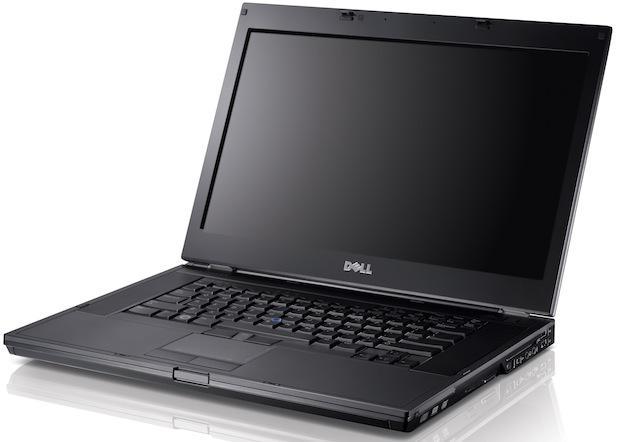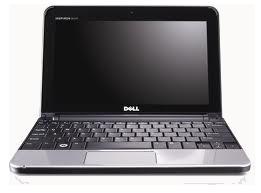The first image is the image on the left, the second image is the image on the right. For the images displayed, is the sentence "All laptops are opened at less than a 90-degree angle, and at least one laptop has its back turned toward the camera." factually correct? Answer yes or no. No. The first image is the image on the left, the second image is the image on the right. Assess this claim about the two images: "One of images shows a laptop with the keyboard facing forward and the other image shows a laptop with the keyboard at an angle.". Correct or not? Answer yes or no. Yes. 